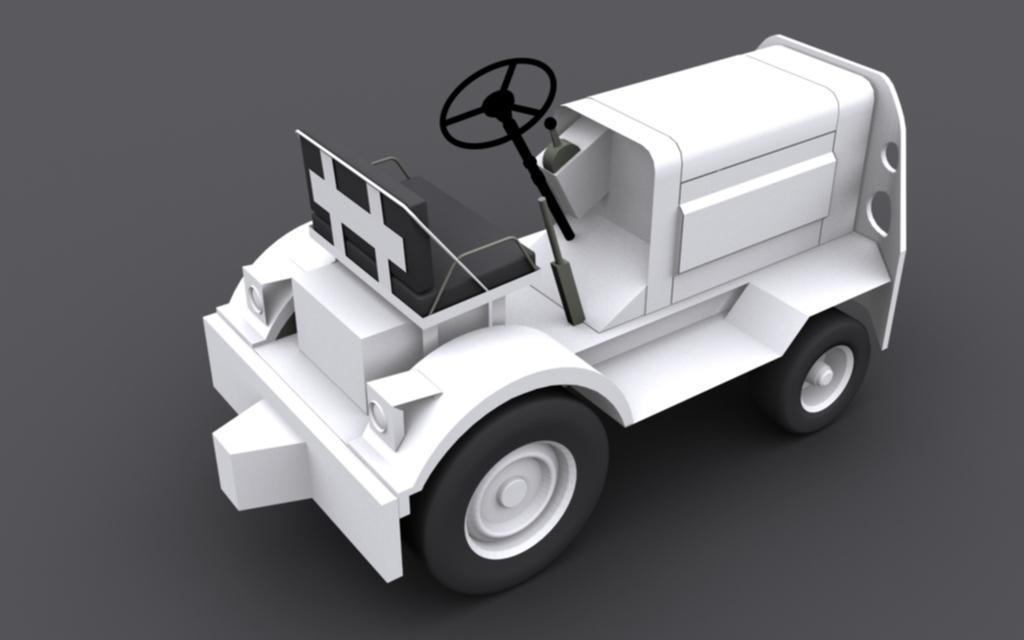How would you summarize this image in a sentence or two? In this picture we can see a toy vehicle with a steering wheel and tires. 